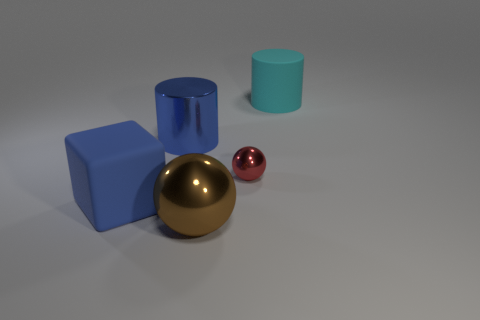Add 4 blue matte objects. How many objects exist? 9 Subtract all balls. How many objects are left? 3 Subtract all large metallic cylinders. Subtract all tiny metallic things. How many objects are left? 3 Add 2 brown objects. How many brown objects are left? 3 Add 5 cyan cylinders. How many cyan cylinders exist? 6 Subtract 0 gray cylinders. How many objects are left? 5 